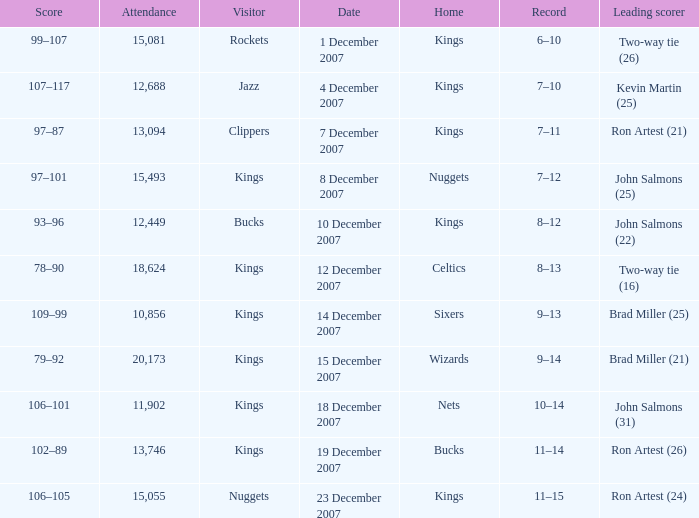What was the record of the game where the Rockets were the visiting team? 6–10. 